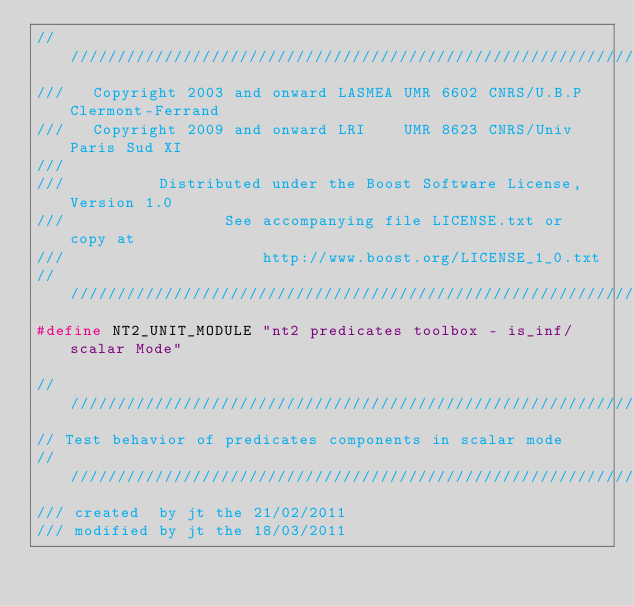Convert code to text. <code><loc_0><loc_0><loc_500><loc_500><_C++_>//////////////////////////////////////////////////////////////////////////////
///   Copyright 2003 and onward LASMEA UMR 6602 CNRS/U.B.P Clermont-Ferrand
///   Copyright 2009 and onward LRI    UMR 8623 CNRS/Univ Paris Sud XI
///
///          Distributed under the Boost Software License, Version 1.0
///                 See accompanying file LICENSE.txt or copy at
///                     http://www.boost.org/LICENSE_1_0.txt
//////////////////////////////////////////////////////////////////////////////
#define NT2_UNIT_MODULE "nt2 predicates toolbox - is_inf/scalar Mode"

//////////////////////////////////////////////////////////////////////////////
// Test behavior of predicates components in scalar mode
//////////////////////////////////////////////////////////////////////////////
/// created  by jt the 21/02/2011
/// modified by jt the 18/03/2011</code> 